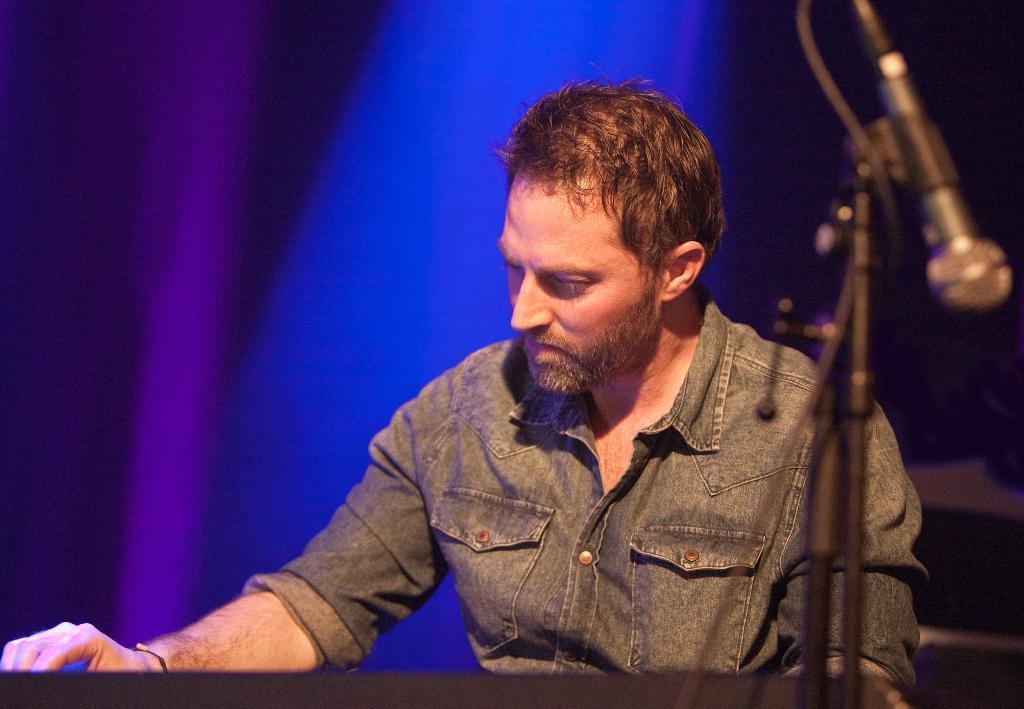Can you describe this image briefly? In this image there is a person sitting, there is a person playing a musical instrument, there is a musical instrument truncated towards the bottom of the image, there is a stand, there is a wire, there is a microphone, there are blue and purple color lights in the background of the image. 